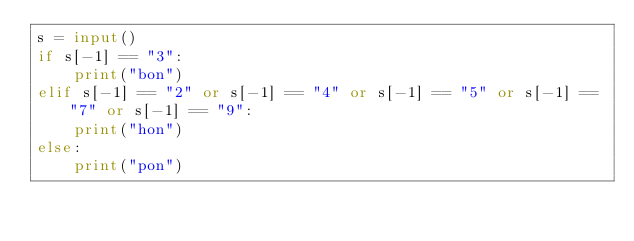<code> <loc_0><loc_0><loc_500><loc_500><_Python_>s = input()
if s[-1] == "3":
    print("bon")
elif s[-1] == "2" or s[-1] == "4" or s[-1] == "5" or s[-1] == "7" or s[-1] == "9":
    print("hon")
else:
    print("pon")</code> 